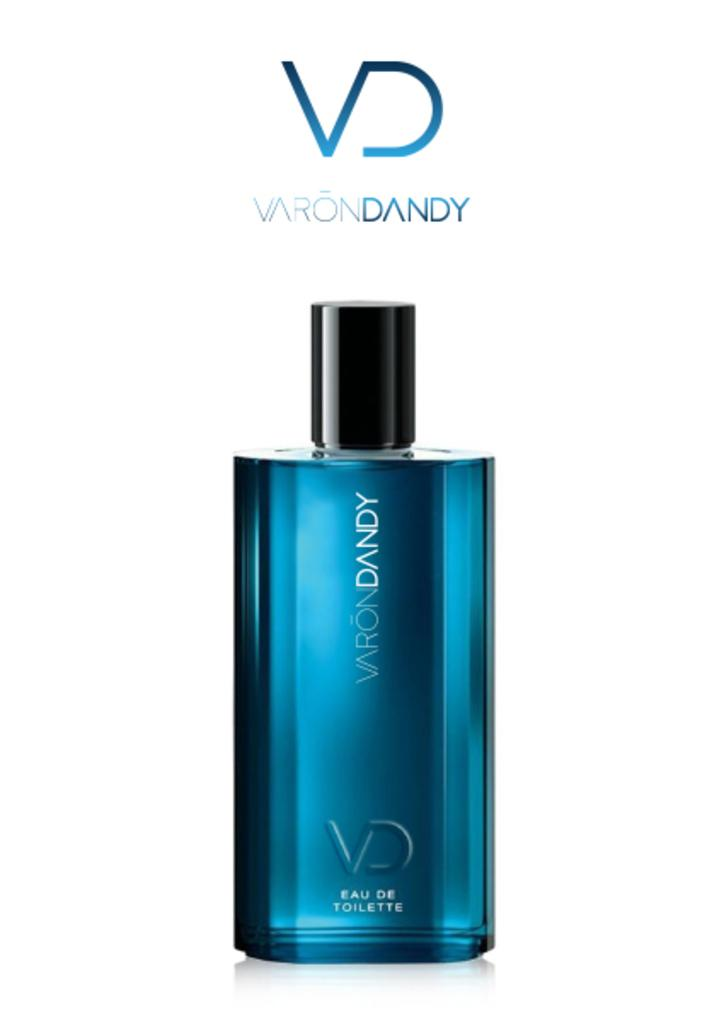<image>
Summarize the visual content of the image. A blue bottle of Varon Dandy perfume is displayed in a white background 